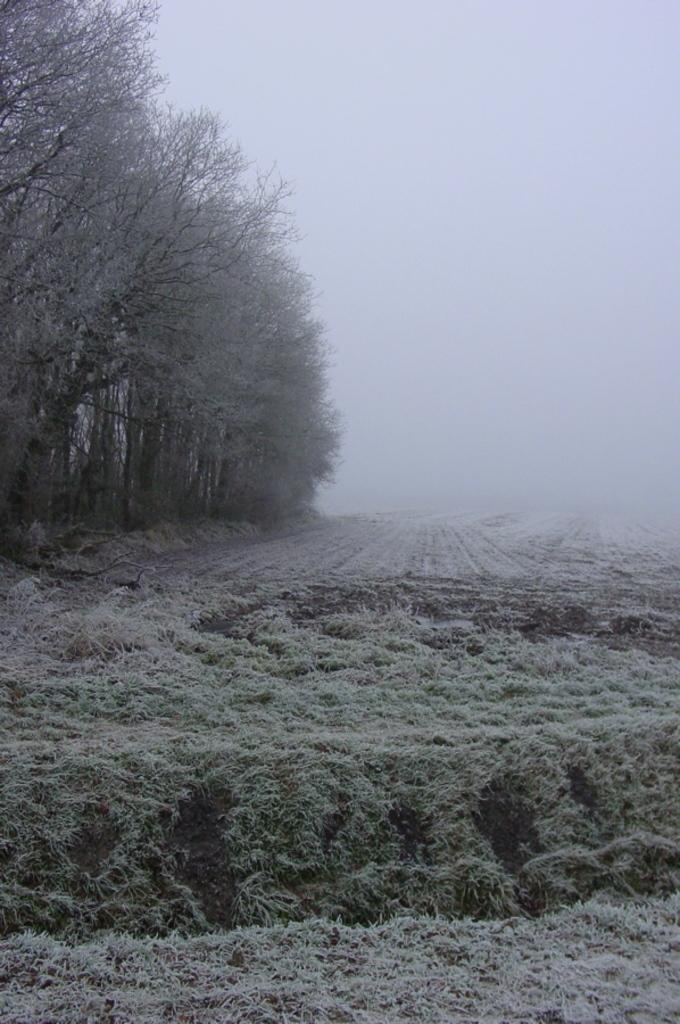What type of landscape is depicted in the image? There is farmland in the image. Where are the majority of trees located in the image? There are many trees on the left side of the image. What type of vegetation can be seen at the bottom of the image? There are plants and grass at the bottom of the image. What atmospheric condition is visible in the top right corner of the image? There is fog visible in the top right corner of the image. Can you see a nest in the trees on the left side of the image? There is no nest visible in the trees on the left side of the image. What type of ground is present in the image? The ground is not specifically mentioned in the image, but it can be inferred that it is likely farmland or grassy terrain based on the visible plants and grass. 